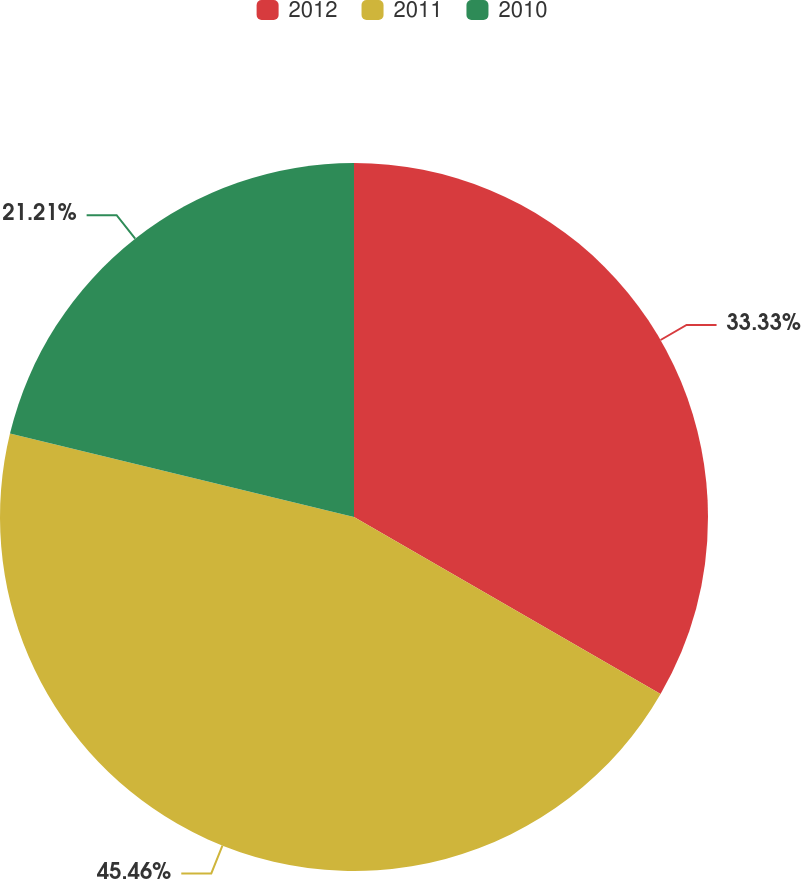Convert chart to OTSL. <chart><loc_0><loc_0><loc_500><loc_500><pie_chart><fcel>2012<fcel>2011<fcel>2010<nl><fcel>33.33%<fcel>45.45%<fcel>21.21%<nl></chart> 